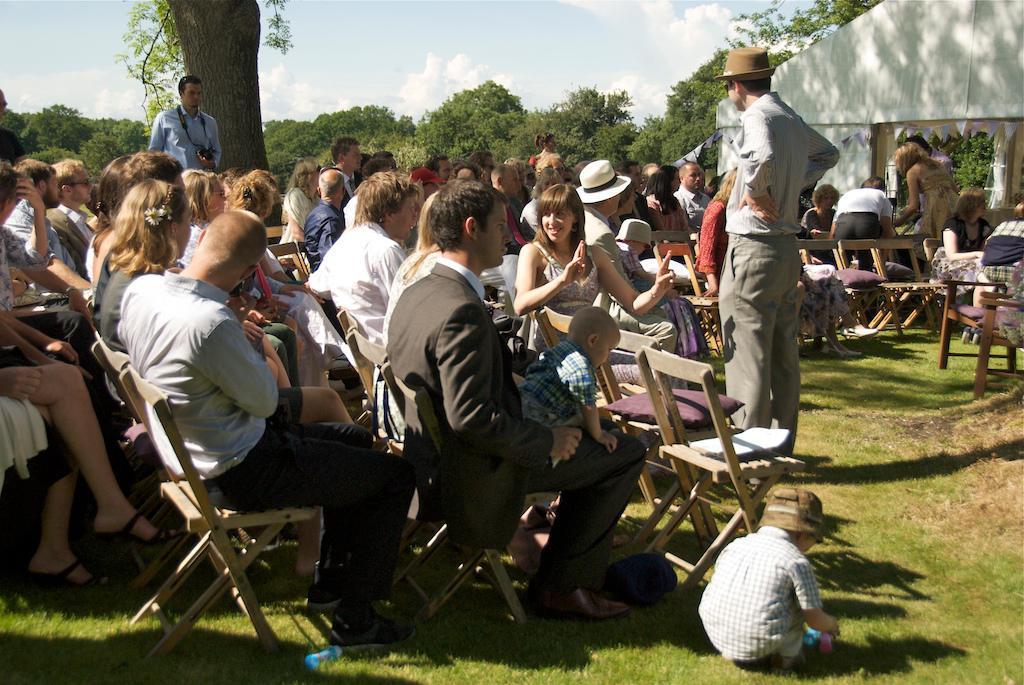Please provide a concise description of this image. In this picture, we see many people are sitting on the chairs. Here, we see a man in the grey shirt is standing and he is wearing a brown hat. At the bottom, we see the grass and a boy is playing. On the right side, we see the people are sitting and three people are standing. Behind them, we see a building in white color. We see a man in the blue shirt is standing and he is holding the camera in his hands. He might be clicking the photos with the camera. There are trees in the background. At the top, we see the sky and the clouds. 